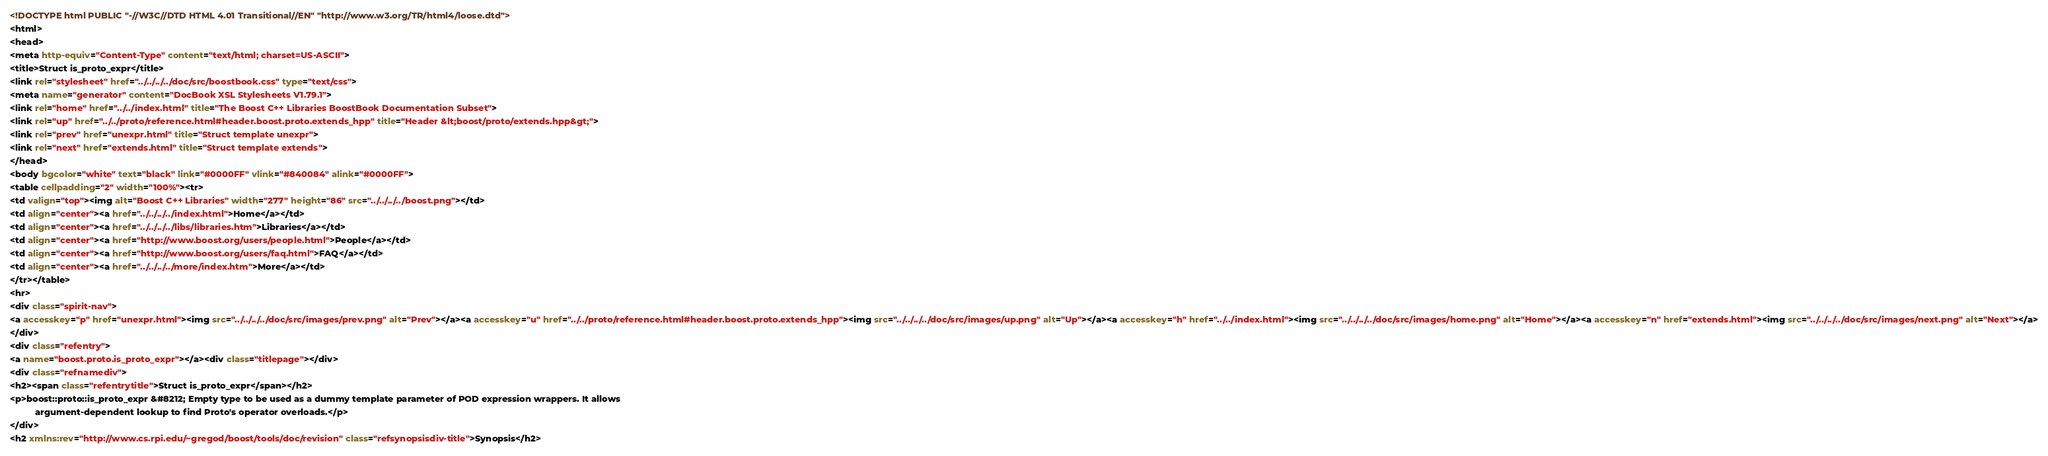<code> <loc_0><loc_0><loc_500><loc_500><_HTML_><!DOCTYPE html PUBLIC "-//W3C//DTD HTML 4.01 Transitional//EN" "http://www.w3.org/TR/html4/loose.dtd">
<html>
<head>
<meta http-equiv="Content-Type" content="text/html; charset=US-ASCII">
<title>Struct is_proto_expr</title>
<link rel="stylesheet" href="../../../../doc/src/boostbook.css" type="text/css">
<meta name="generator" content="DocBook XSL Stylesheets V1.79.1">
<link rel="home" href="../../index.html" title="The Boost C++ Libraries BoostBook Documentation Subset">
<link rel="up" href="../../proto/reference.html#header.boost.proto.extends_hpp" title="Header &lt;boost/proto/extends.hpp&gt;">
<link rel="prev" href="unexpr.html" title="Struct template unexpr">
<link rel="next" href="extends.html" title="Struct template extends">
</head>
<body bgcolor="white" text="black" link="#0000FF" vlink="#840084" alink="#0000FF">
<table cellpadding="2" width="100%"><tr>
<td valign="top"><img alt="Boost C++ Libraries" width="277" height="86" src="../../../../boost.png"></td>
<td align="center"><a href="../../../../index.html">Home</a></td>
<td align="center"><a href="../../../../libs/libraries.htm">Libraries</a></td>
<td align="center"><a href="http://www.boost.org/users/people.html">People</a></td>
<td align="center"><a href="http://www.boost.org/users/faq.html">FAQ</a></td>
<td align="center"><a href="../../../../more/index.htm">More</a></td>
</tr></table>
<hr>
<div class="spirit-nav">
<a accesskey="p" href="unexpr.html"><img src="../../../../doc/src/images/prev.png" alt="Prev"></a><a accesskey="u" href="../../proto/reference.html#header.boost.proto.extends_hpp"><img src="../../../../doc/src/images/up.png" alt="Up"></a><a accesskey="h" href="../../index.html"><img src="../../../../doc/src/images/home.png" alt="Home"></a><a accesskey="n" href="extends.html"><img src="../../../../doc/src/images/next.png" alt="Next"></a>
</div>
<div class="refentry">
<a name="boost.proto.is_proto_expr"></a><div class="titlepage"></div>
<div class="refnamediv">
<h2><span class="refentrytitle">Struct is_proto_expr</span></h2>
<p>boost::proto::is_proto_expr &#8212; Empty type to be used as a dummy template parameter of POD expression wrappers. It allows
          argument-dependent lookup to find Proto's operator overloads.</p>
</div>
<h2 xmlns:rev="http://www.cs.rpi.edu/~gregod/boost/tools/doc/revision" class="refsynopsisdiv-title">Synopsis</h2></code> 